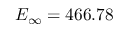<formula> <loc_0><loc_0><loc_500><loc_500>E _ { \infty } = 4 6 6 . 7 8</formula> 